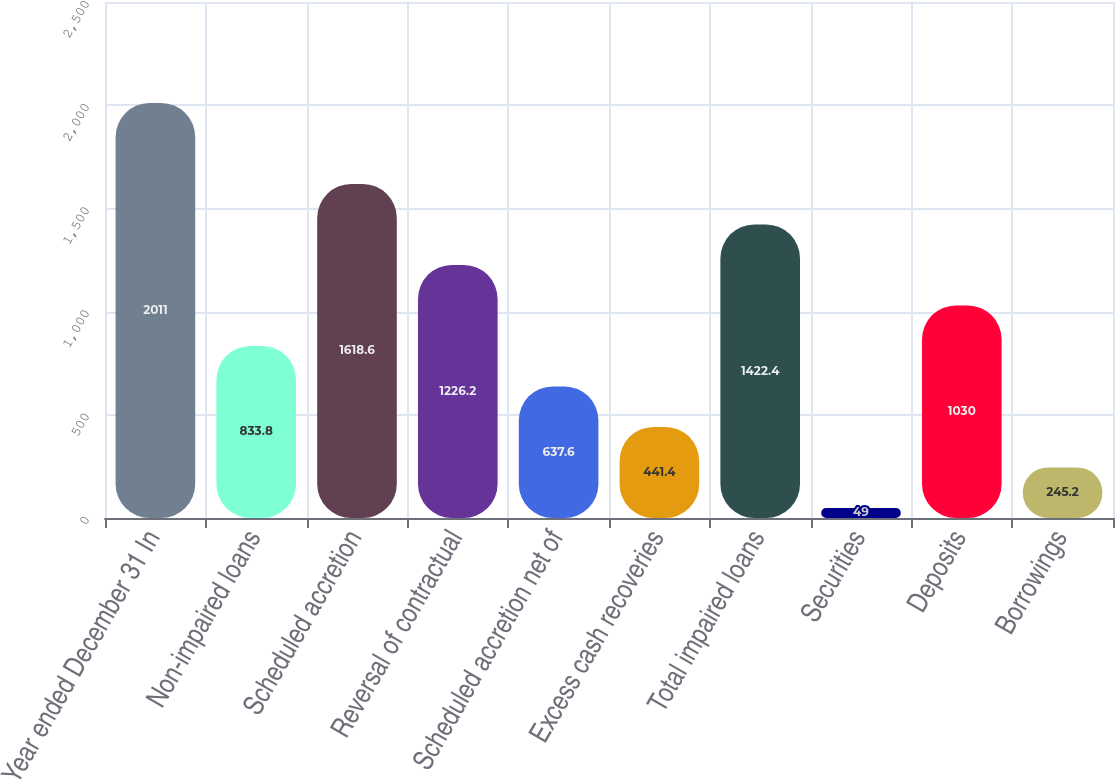Convert chart. <chart><loc_0><loc_0><loc_500><loc_500><bar_chart><fcel>Year ended December 31 In<fcel>Non-impaired loans<fcel>Scheduled accretion<fcel>Reversal of contractual<fcel>Scheduled accretion net of<fcel>Excess cash recoveries<fcel>Total impaired loans<fcel>Securities<fcel>Deposits<fcel>Borrowings<nl><fcel>2011<fcel>833.8<fcel>1618.6<fcel>1226.2<fcel>637.6<fcel>441.4<fcel>1422.4<fcel>49<fcel>1030<fcel>245.2<nl></chart> 